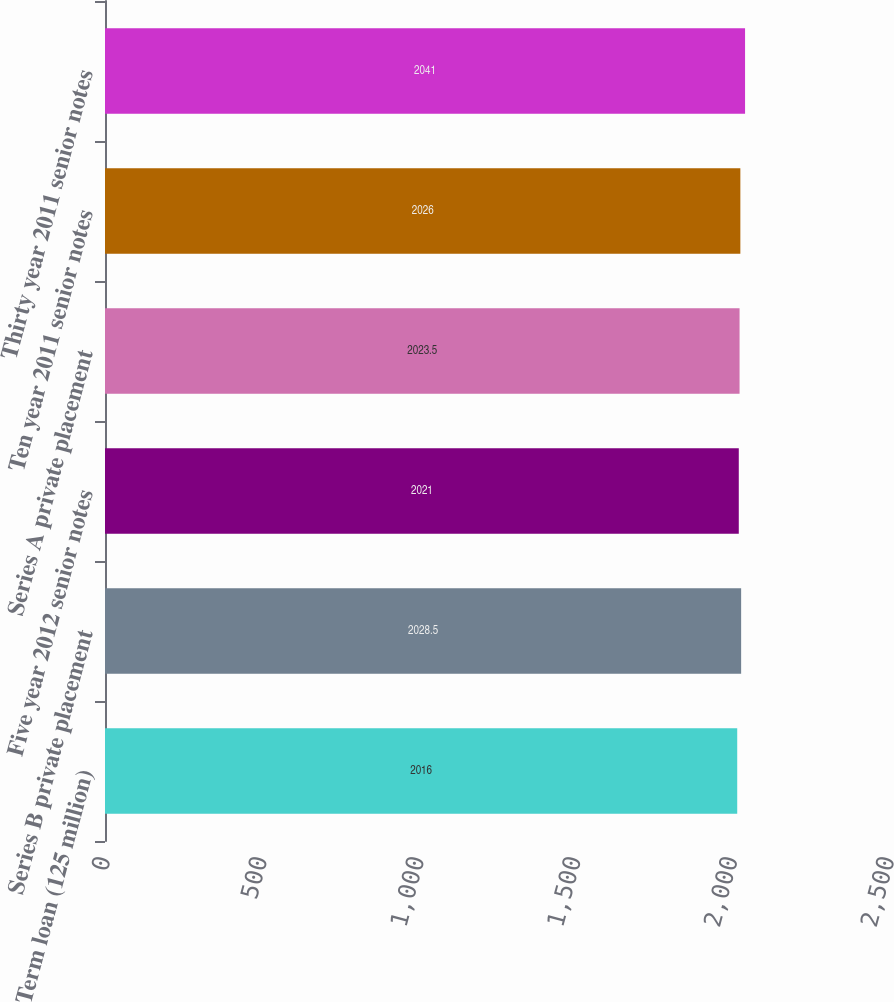Convert chart. <chart><loc_0><loc_0><loc_500><loc_500><bar_chart><fcel>Term loan (125 million)<fcel>Series B private placement<fcel>Five year 2012 senior notes<fcel>Series A private placement<fcel>Ten year 2011 senior notes<fcel>Thirty year 2011 senior notes<nl><fcel>2016<fcel>2028.5<fcel>2021<fcel>2023.5<fcel>2026<fcel>2041<nl></chart> 